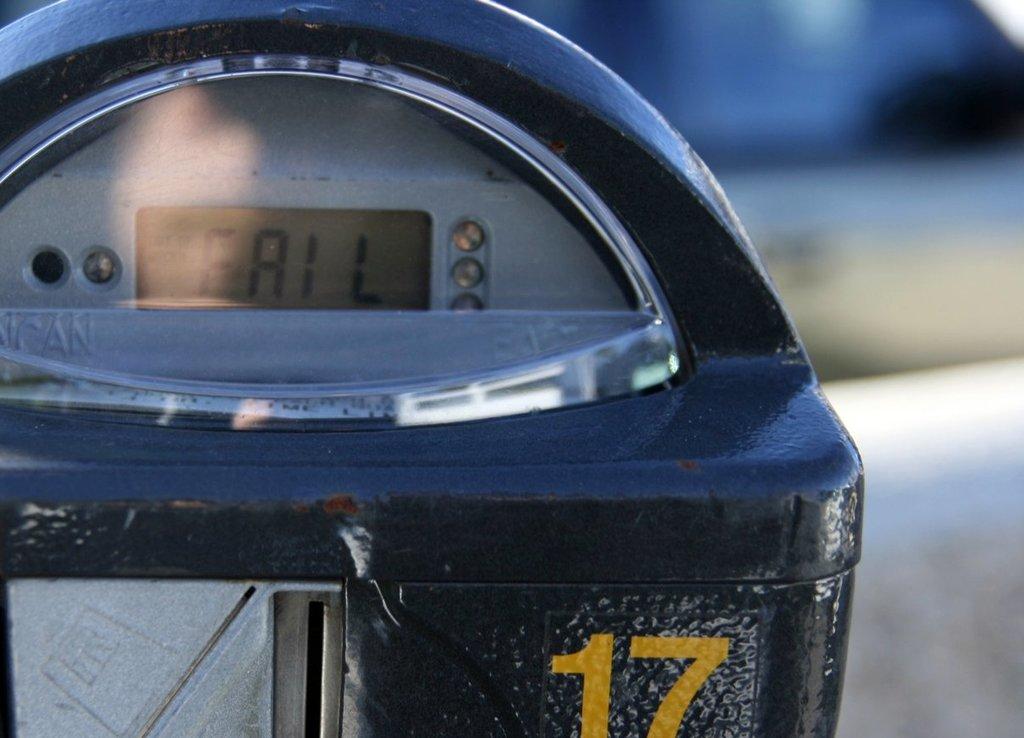What's the number in yellow?
Keep it short and to the point. 17. Does the meter read pass or fail?
Provide a succinct answer. Fail. 